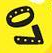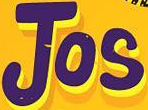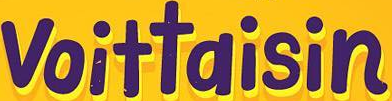What text is displayed in these images sequentially, separated by a semicolon? 07; Jos; voittaisin 